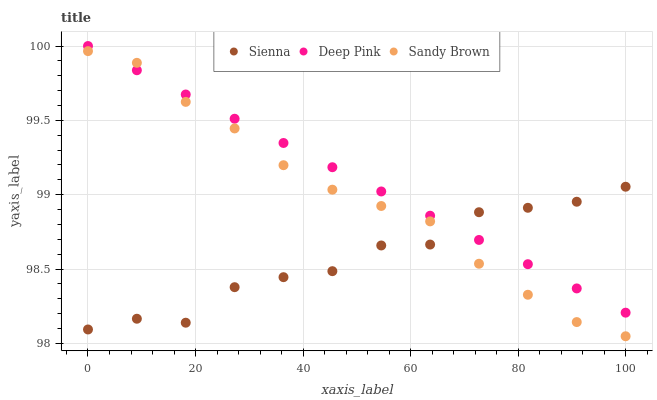Does Sienna have the minimum area under the curve?
Answer yes or no. Yes. Does Deep Pink have the maximum area under the curve?
Answer yes or no. Yes. Does Sandy Brown have the minimum area under the curve?
Answer yes or no. No. Does Sandy Brown have the maximum area under the curve?
Answer yes or no. No. Is Deep Pink the smoothest?
Answer yes or no. Yes. Is Sienna the roughest?
Answer yes or no. Yes. Is Sandy Brown the smoothest?
Answer yes or no. No. Is Sandy Brown the roughest?
Answer yes or no. No. Does Sandy Brown have the lowest value?
Answer yes or no. Yes. Does Deep Pink have the lowest value?
Answer yes or no. No. Does Deep Pink have the highest value?
Answer yes or no. Yes. Does Sandy Brown have the highest value?
Answer yes or no. No. Does Deep Pink intersect Sandy Brown?
Answer yes or no. Yes. Is Deep Pink less than Sandy Brown?
Answer yes or no. No. Is Deep Pink greater than Sandy Brown?
Answer yes or no. No. 